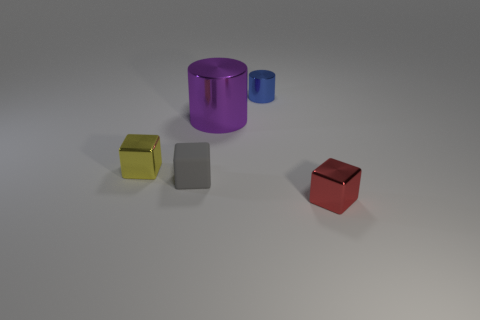Add 3 yellow cylinders. How many objects exist? 8 Subtract all cylinders. How many objects are left? 3 Add 2 tiny gray objects. How many tiny gray objects exist? 3 Subtract 0 blue blocks. How many objects are left? 5 Subtract all gray shiny cubes. Subtract all tiny gray matte objects. How many objects are left? 4 Add 3 red cubes. How many red cubes are left? 4 